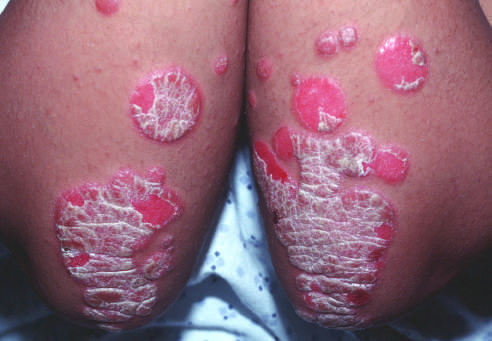what is covered by silvery-white scale?
Answer the question using a single word or phrase. Erythematous psoriatic plaques 